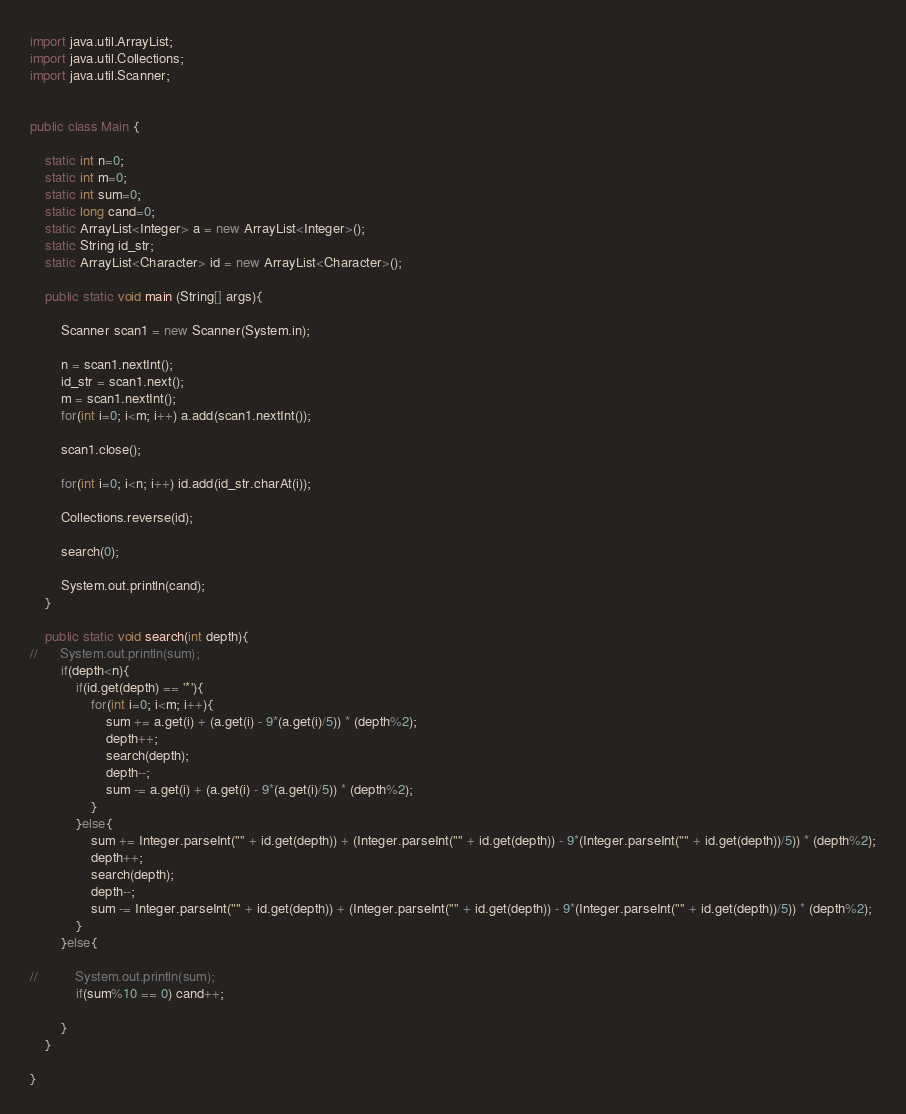Convert code to text. <code><loc_0><loc_0><loc_500><loc_500><_Java_>import java.util.ArrayList;
import java.util.Collections;
import java.util.Scanner;


public class Main {
	
	static int n=0;
	static int m=0;
	static int sum=0;
	static long cand=0;
	static ArrayList<Integer> a = new ArrayList<Integer>();
	static String id_str;
	static ArrayList<Character> id = new ArrayList<Character>();
	
	public static void main (String[] args){
		
		Scanner scan1 = new Scanner(System.in);
		
		n = scan1.nextInt();
		id_str = scan1.next();
		m = scan1.nextInt();
		for(int i=0; i<m; i++) a.add(scan1.nextInt());

		scan1.close();
		
		for(int i=0; i<n; i++) id.add(id_str.charAt(i));
		
		Collections.reverse(id);

		search(0);
		
		System.out.println(cand);
	}
	
	public static void search(int depth){
//		System.out.println(sum);
		if(depth<n){
			if(id.get(depth) == '*'){
				for(int i=0; i<m; i++){
					sum += a.get(i) + (a.get(i) - 9*(a.get(i)/5)) * (depth%2);
					depth++;
					search(depth);
					depth--;
					sum -= a.get(i) + (a.get(i) - 9*(a.get(i)/5)) * (depth%2);
				}
			}else{
				sum += Integer.parseInt("" + id.get(depth)) + (Integer.parseInt("" + id.get(depth)) - 9*(Integer.parseInt("" + id.get(depth))/5)) * (depth%2);
				depth++;
				search(depth);
				depth--;
				sum -= Integer.parseInt("" + id.get(depth)) + (Integer.parseInt("" + id.get(depth)) - 9*(Integer.parseInt("" + id.get(depth))/5)) * (depth%2);
			}
		}else{

//			System.out.println(sum);
			if(sum%10 == 0) cand++;

		}
	}
	
}</code> 